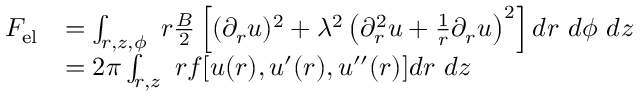<formula> <loc_0><loc_0><loc_500><loc_500>\begin{array} { r l } { { F } _ { e l } } & { = \int _ { r , z , \phi } \ r \frac { B } { 2 } \left [ ( \partial _ { r } u ) ^ { 2 } + \lambda ^ { 2 } \left ( \partial _ { r } ^ { 2 } u + \frac { 1 } { r } \partial _ { r } u \right ) ^ { 2 } \right ] d r \ d \phi \ d z } \\ & { = 2 \pi \int _ { r , z } \ r f [ u ( r ) , u ^ { \prime } ( r ) , u ^ { \prime \prime } ( r ) ] d r \ d z } \end{array}</formula> 